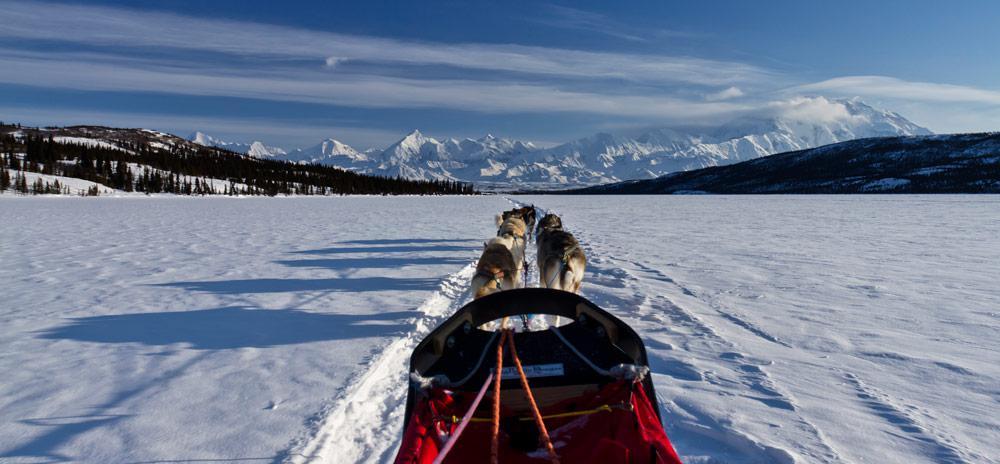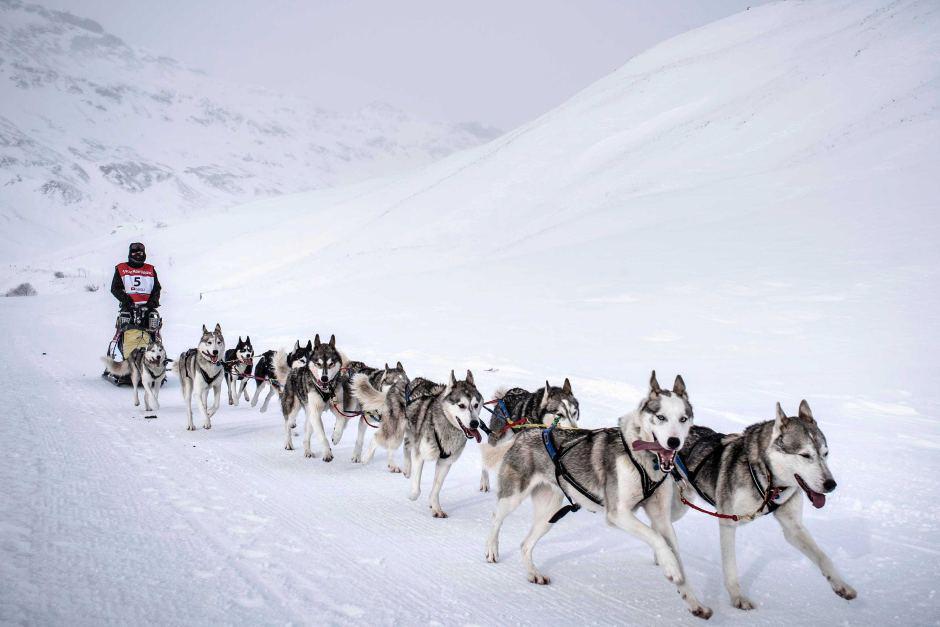The first image is the image on the left, the second image is the image on the right. Given the left and right images, does the statement "A building with a snow-covered peaked roof is in the background of an image with at least one sled dog team racing across the snow." hold true? Answer yes or no. No. The first image is the image on the left, the second image is the image on the right. For the images displayed, is the sentence "A dogsled is traveling slightly to the right in at least one of the images." factually correct? Answer yes or no. Yes. 